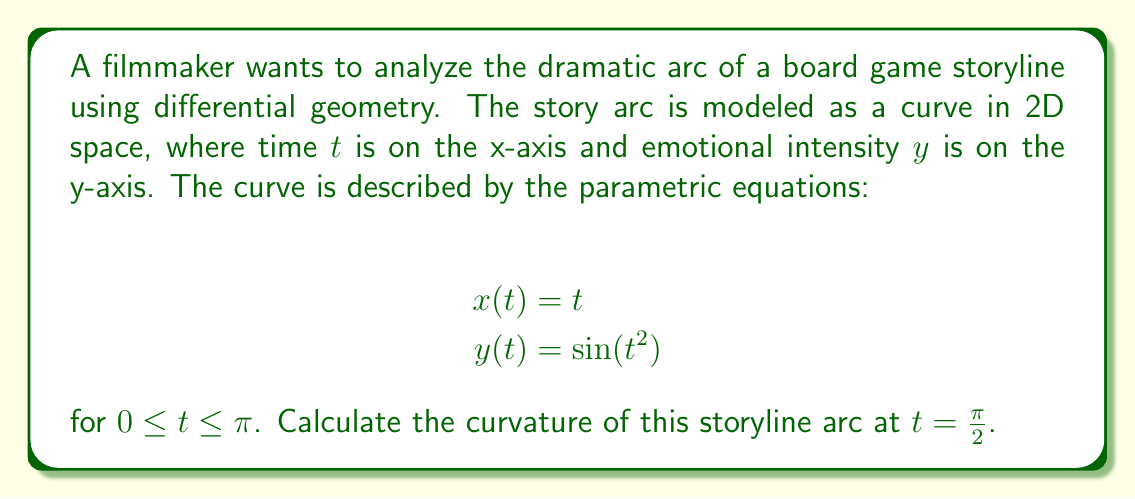Teach me how to tackle this problem. To calculate the curvature of the storyline arc, we'll follow these steps:

1) The curvature κ of a parametric curve is given by:

   $$κ = \frac{|x'y'' - y'x''|}{(x'^2 + y'^2)^{3/2}}$$

2) We need to calculate x', x'', y', and y':
   
   $$x' = \frac{dx}{dt} = 1$$
   $$x'' = \frac{d^2x}{dt^2} = 0$$
   $$y' = \frac{dy}{dt} = 2t \cos(t^2)$$
   $$y'' = \frac{d^2y}{dt^2} = 2\cos(t^2) - 4t^2\sin(t^2)$$

3) Substitute these into the curvature formula:

   $$κ = \frac{|1 \cdot (2\cos(t^2) - 4t^2\sin(t^2)) - 2t\cos(t^2) \cdot 0|}{(1^2 + (2t\cos(t^2))^2)^{3/2}}$$

4) Simplify:

   $$κ = \frac{|2\cos(t^2) - 4t^2\sin(t^2)|}{(1 + 4t^2\cos^2(t^2))^{3/2}}$$

5) Now, evaluate at $t = \frac{\pi}{2}$:

   $$κ = \frac{|2\cos((\frac{\pi}{2})^2) - 4(\frac{\pi}{2})^2\sin((\frac{\pi}{2})^2)|}{(1 + 4(\frac{\pi}{2})^2\cos^2((\frac{\pi}{2})^2))^{3/2}}$$

6) Simplify:

   $$κ = \frac{|2\cos(\frac{\pi^2}{4}) - \pi^2\sin(\frac{\pi^2}{4})|}{(1 + \pi^2\cos^2(\frac{\pi^2}{4}))^{3/2}}$$

This is the final expression for the curvature at $t = \frac{\pi}{2}$.
Answer: $$\frac{|2\cos(\frac{\pi^2}{4}) - \pi^2\sin(\frac{\pi^2}{4})|}{(1 + \pi^2\cos^2(\frac{\pi^2}{4}))^{3/2}}$$ 